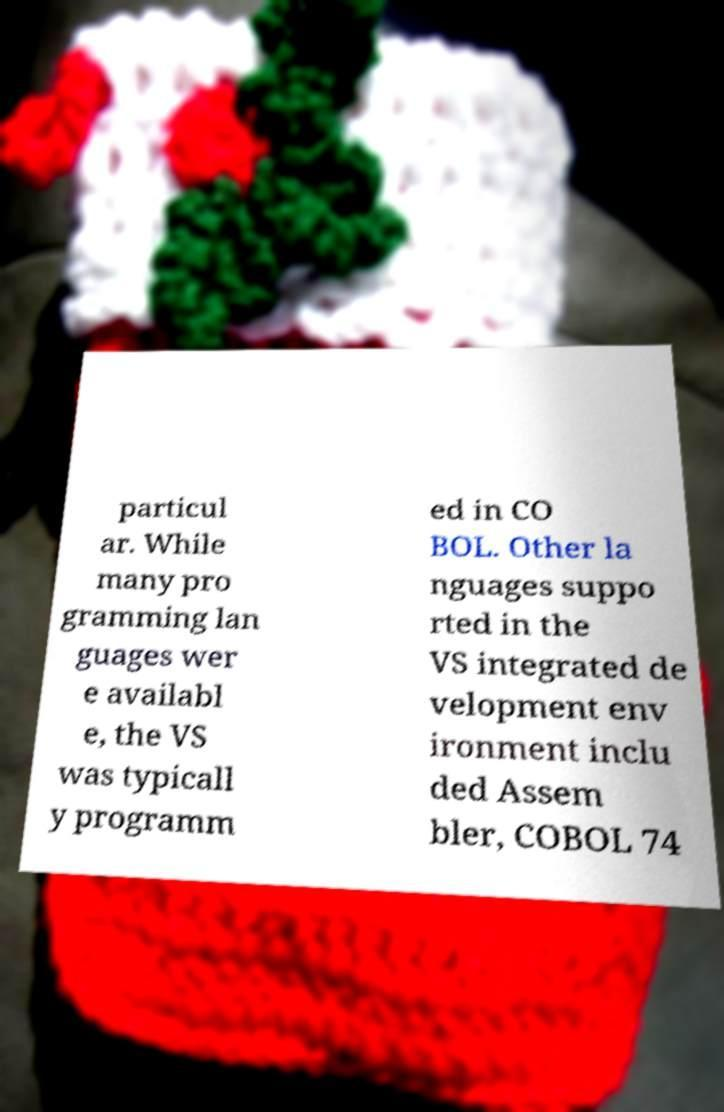Can you read and provide the text displayed in the image?This photo seems to have some interesting text. Can you extract and type it out for me? particul ar. While many pro gramming lan guages wer e availabl e, the VS was typicall y programm ed in CO BOL. Other la nguages suppo rted in the VS integrated de velopment env ironment inclu ded Assem bler, COBOL 74 